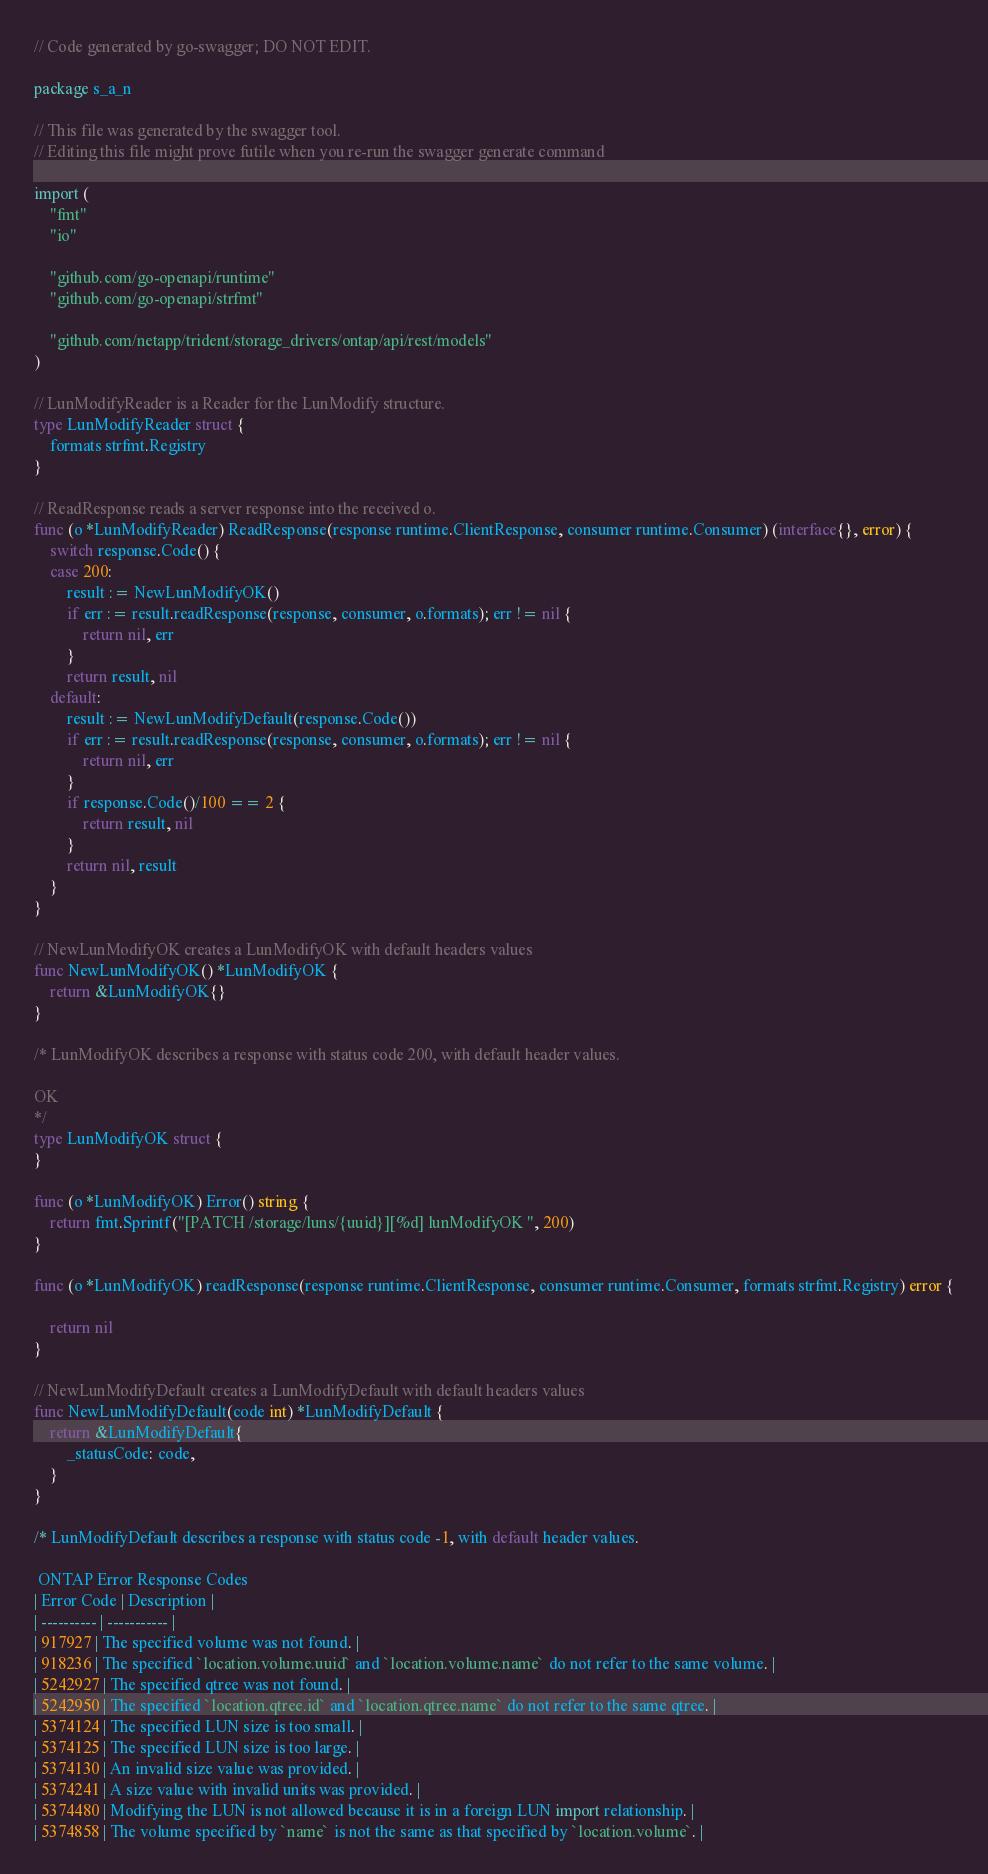Convert code to text. <code><loc_0><loc_0><loc_500><loc_500><_Go_>// Code generated by go-swagger; DO NOT EDIT.

package s_a_n

// This file was generated by the swagger tool.
// Editing this file might prove futile when you re-run the swagger generate command

import (
	"fmt"
	"io"

	"github.com/go-openapi/runtime"
	"github.com/go-openapi/strfmt"

	"github.com/netapp/trident/storage_drivers/ontap/api/rest/models"
)

// LunModifyReader is a Reader for the LunModify structure.
type LunModifyReader struct {
	formats strfmt.Registry
}

// ReadResponse reads a server response into the received o.
func (o *LunModifyReader) ReadResponse(response runtime.ClientResponse, consumer runtime.Consumer) (interface{}, error) {
	switch response.Code() {
	case 200:
		result := NewLunModifyOK()
		if err := result.readResponse(response, consumer, o.formats); err != nil {
			return nil, err
		}
		return result, nil
	default:
		result := NewLunModifyDefault(response.Code())
		if err := result.readResponse(response, consumer, o.formats); err != nil {
			return nil, err
		}
		if response.Code()/100 == 2 {
			return result, nil
		}
		return nil, result
	}
}

// NewLunModifyOK creates a LunModifyOK with default headers values
func NewLunModifyOK() *LunModifyOK {
	return &LunModifyOK{}
}

/* LunModifyOK describes a response with status code 200, with default header values.

OK
*/
type LunModifyOK struct {
}

func (o *LunModifyOK) Error() string {
	return fmt.Sprintf("[PATCH /storage/luns/{uuid}][%d] lunModifyOK ", 200)
}

func (o *LunModifyOK) readResponse(response runtime.ClientResponse, consumer runtime.Consumer, formats strfmt.Registry) error {

	return nil
}

// NewLunModifyDefault creates a LunModifyDefault with default headers values
func NewLunModifyDefault(code int) *LunModifyDefault {
	return &LunModifyDefault{
		_statusCode: code,
	}
}

/* LunModifyDefault describes a response with status code -1, with default header values.

 ONTAP Error Response Codes
| Error Code | Description |
| ---------- | ----------- |
| 917927 | The specified volume was not found. |
| 918236 | The specified `location.volume.uuid` and `location.volume.name` do not refer to the same volume. |
| 5242927 | The specified qtree was not found. |
| 5242950 | The specified `location.qtree.id` and `location.qtree.name` do not refer to the same qtree. |
| 5374124 | The specified LUN size is too small. |
| 5374125 | The specified LUN size is too large. |
| 5374130 | An invalid size value was provided. |
| 5374241 | A size value with invalid units was provided. |
| 5374480 | Modifying the LUN is not allowed because it is in a foreign LUN import relationship. |
| 5374858 | The volume specified by `name` is not the same as that specified by `location.volume`. |</code> 